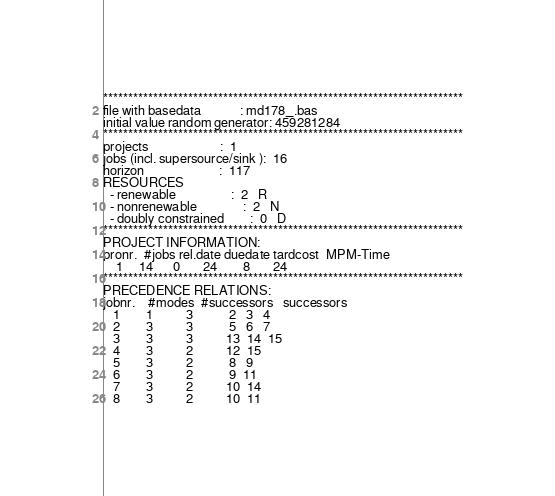Convert code to text. <code><loc_0><loc_0><loc_500><loc_500><_ObjectiveC_>************************************************************************
file with basedata            : md178_.bas
initial value random generator: 459281284
************************************************************************
projects                      :  1
jobs (incl. supersource/sink ):  16
horizon                       :  117
RESOURCES
  - renewable                 :  2   R
  - nonrenewable              :  2   N
  - doubly constrained        :  0   D
************************************************************************
PROJECT INFORMATION:
pronr.  #jobs rel.date duedate tardcost  MPM-Time
    1     14      0       24        8       24
************************************************************************
PRECEDENCE RELATIONS:
jobnr.    #modes  #successors   successors
   1        1          3           2   3   4
   2        3          3           5   6   7
   3        3          3          13  14  15
   4        3          2          12  15
   5        3          2           8   9
   6        3          2           9  11
   7        3          2          10  14
   8        3          2          10  11</code> 